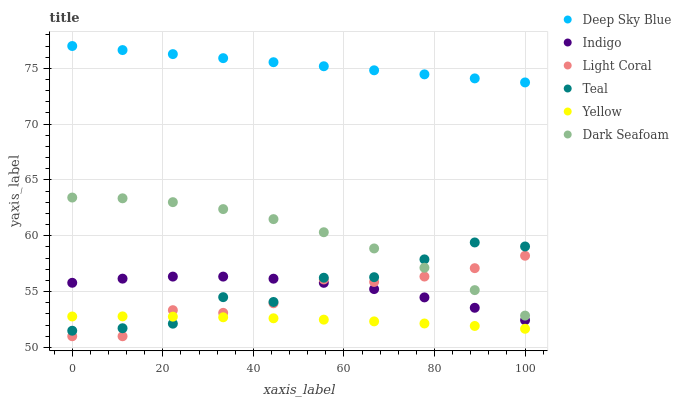Does Yellow have the minimum area under the curve?
Answer yes or no. Yes. Does Deep Sky Blue have the maximum area under the curve?
Answer yes or no. Yes. Does Deep Sky Blue have the minimum area under the curve?
Answer yes or no. No. Does Yellow have the maximum area under the curve?
Answer yes or no. No. Is Deep Sky Blue the smoothest?
Answer yes or no. Yes. Is Teal the roughest?
Answer yes or no. Yes. Is Yellow the smoothest?
Answer yes or no. No. Is Yellow the roughest?
Answer yes or no. No. Does Light Coral have the lowest value?
Answer yes or no. Yes. Does Yellow have the lowest value?
Answer yes or no. No. Does Deep Sky Blue have the highest value?
Answer yes or no. Yes. Does Yellow have the highest value?
Answer yes or no. No. Is Teal less than Deep Sky Blue?
Answer yes or no. Yes. Is Dark Seafoam greater than Indigo?
Answer yes or no. Yes. Does Light Coral intersect Yellow?
Answer yes or no. Yes. Is Light Coral less than Yellow?
Answer yes or no. No. Is Light Coral greater than Yellow?
Answer yes or no. No. Does Teal intersect Deep Sky Blue?
Answer yes or no. No. 